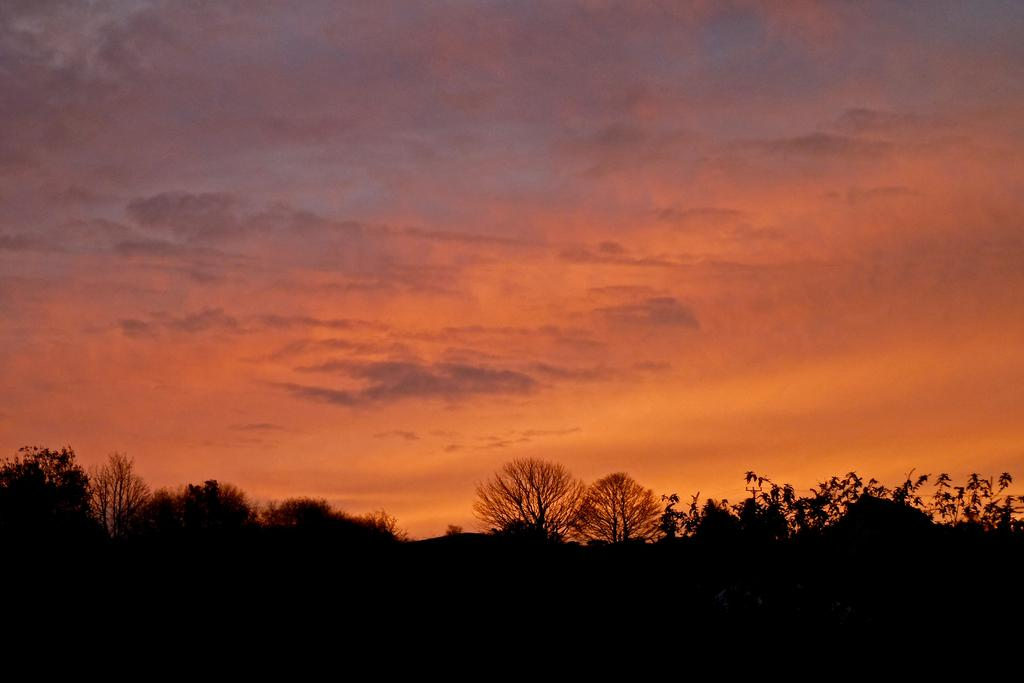What type of vegetation can be seen in the image? There are trees in the image. How would you describe the sky in the image? The sky is cloudy and pale orange in color. How many trucks are parked near the trees in the image? There are no trucks present in the image; it only features trees and a cloudy, pale orange sky. What type of gold jewelry is visible on the trees in the image? There is no gold jewelry present on the trees in the image; it only features trees and a cloudy, pale orange sky. 